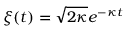Convert formula to latex. <formula><loc_0><loc_0><loc_500><loc_500>\xi ( t ) = \sqrt { 2 \kappa } e ^ { - \kappa t }</formula> 